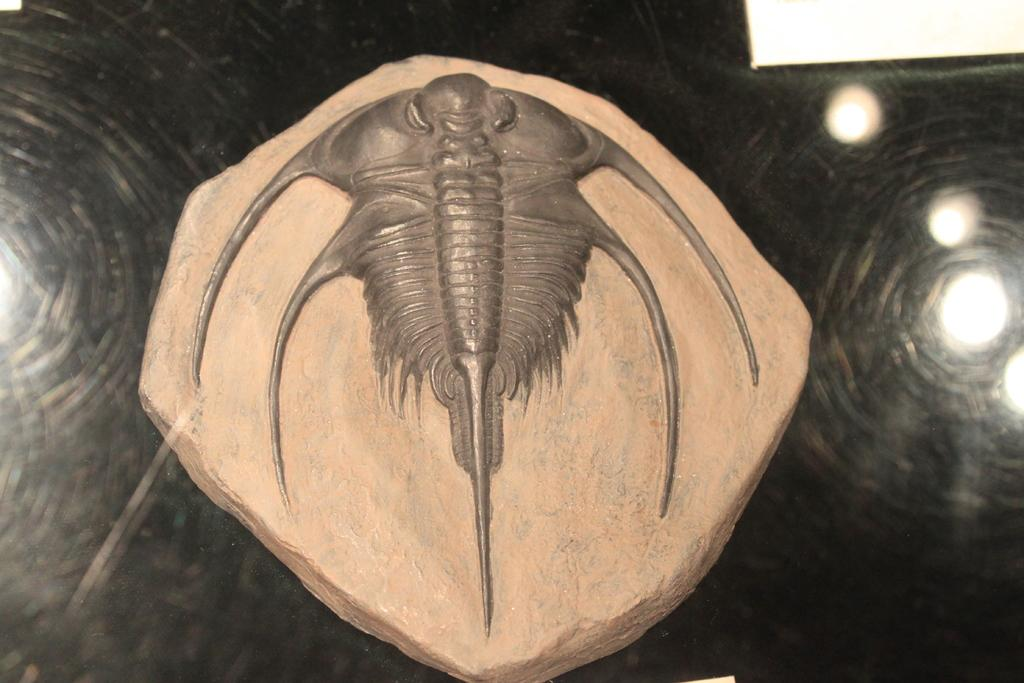What type of craft is featured in the image? There is a stone craft in the image. What can be seen illuminating the scene in the image? There are lights visible in the image. What type of container is present in the image? There is a glass in the image. Can you determine the time of day based on the image? The image may have been taken during the night, as the lights are visible. What type of jeans is the crow wearing in the image? There is no crow or jeans present in the image. 